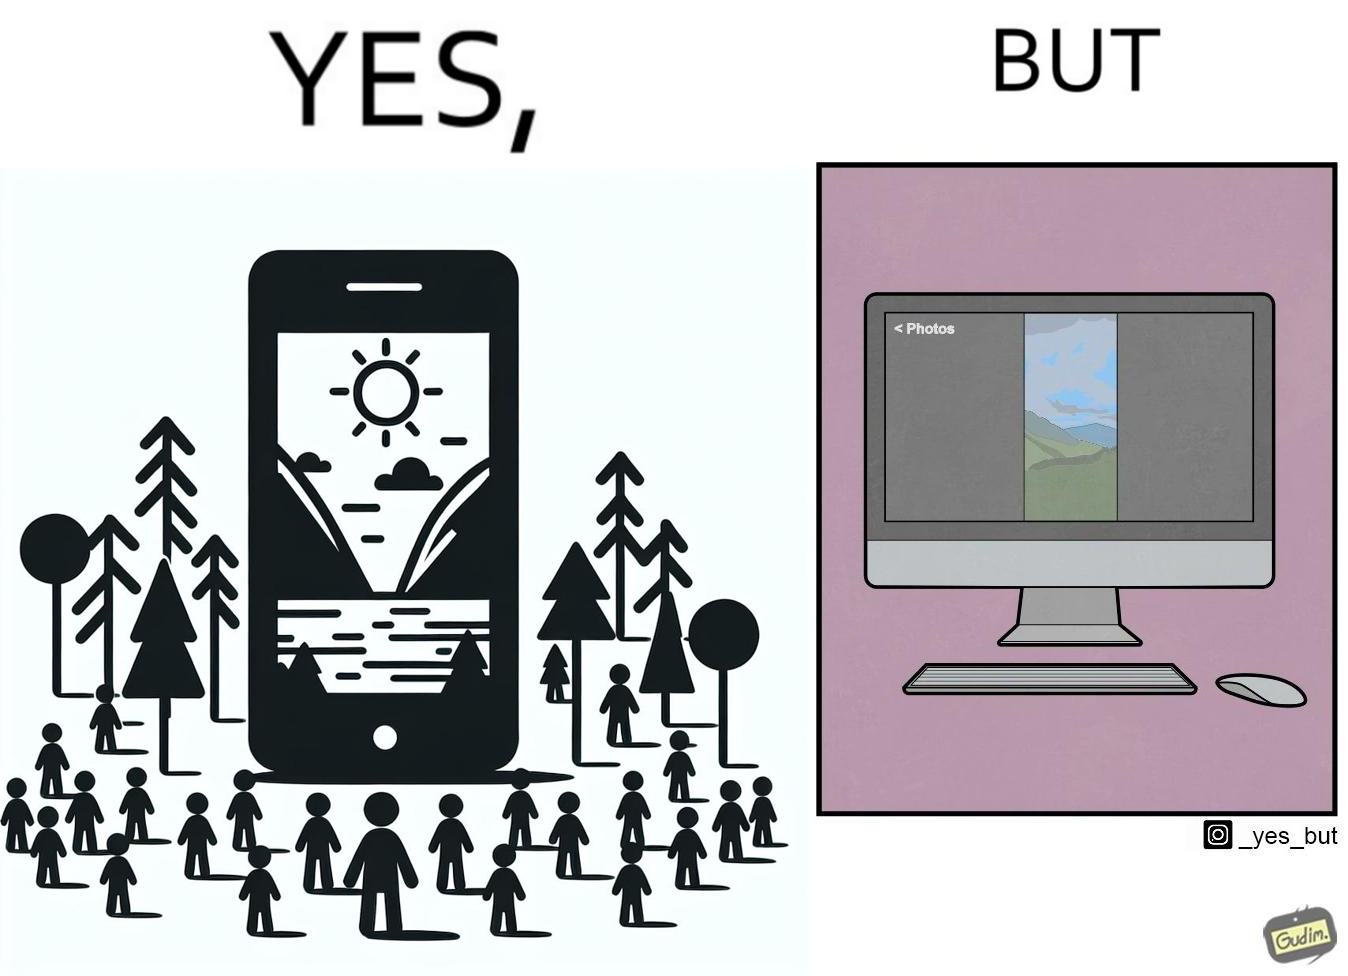What does this image depict? This image is funny, as when using the "photos" app on mobile, it shows you images perfectly, which fill the entire screen, but when viewing the same photos on the computer monitor, the same images have a very limited coverage of the screen. 